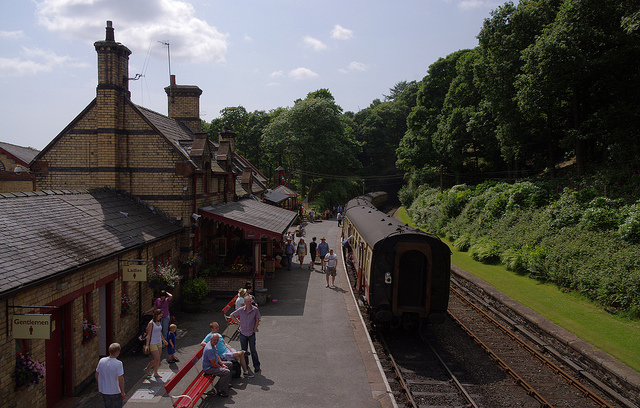<image>What does the sign say? It is impossible to tell exactly what the sign says. It might say 'gentlemen', 'ladies' or 'train'. What does the sign say? It is ambiguous what the sign says. It can be seen as 'gentlemen', 'ladies' or 'restroom'. 